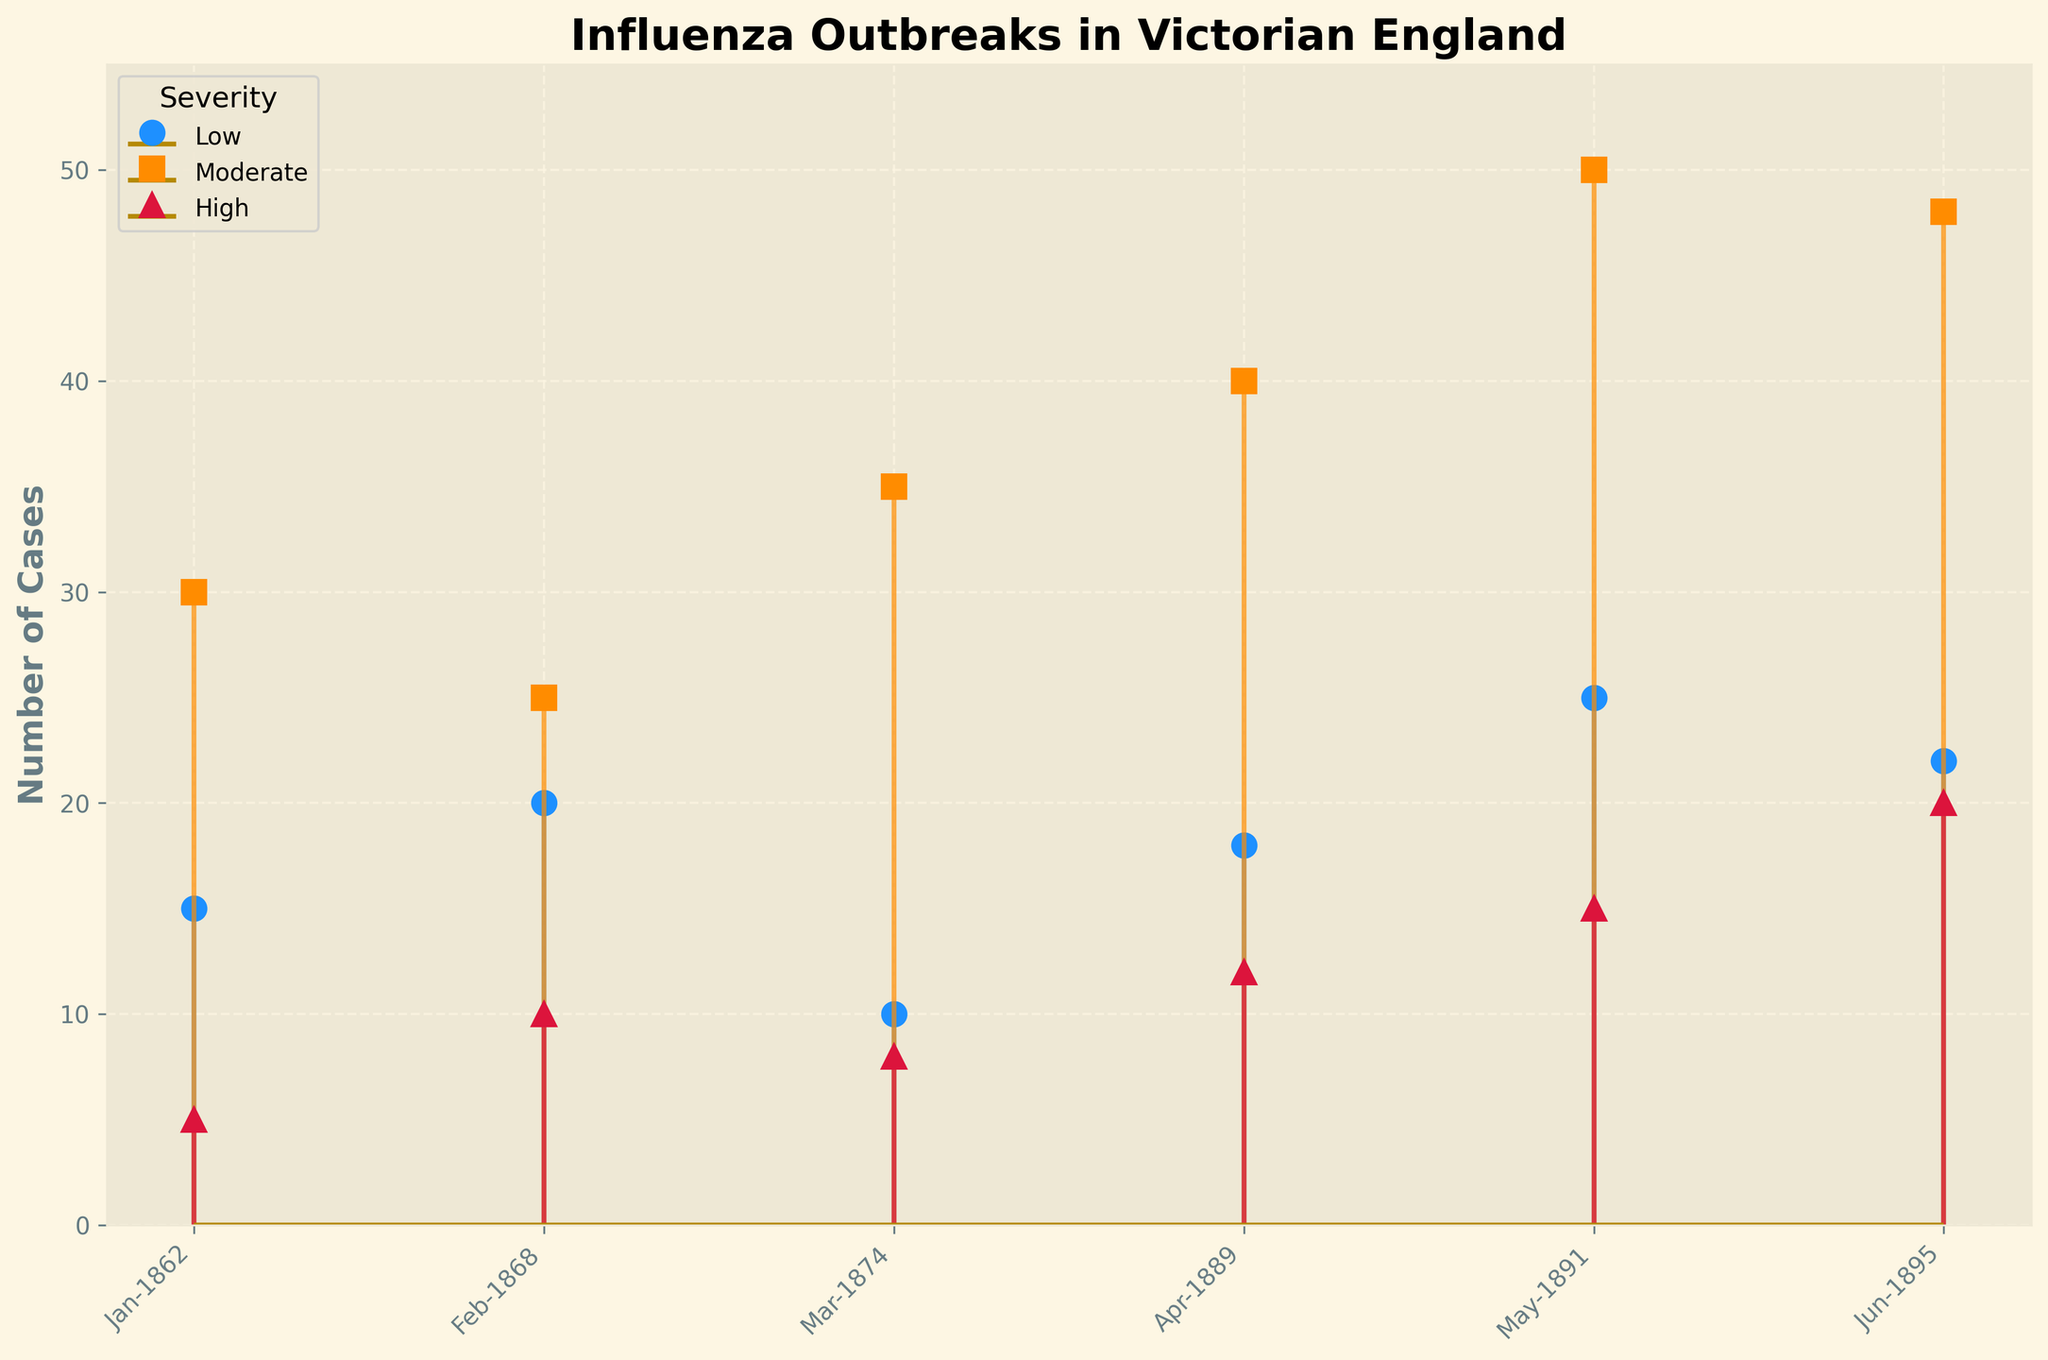What is the title of the figure? The title of the figure is prominently displayed at the top. It reads "Influenza Outbreaks in Victorian England."
Answer: Influenza Outbreaks in Victorian England How many cases of high severity occurred in May-1891? By identifying "May-1891" on the x-axis and looking at the corresponding value for high severity, we observe that it reaches up to the line marked with the highest number of cases, which is 15.
Answer: 15 Which month had the highest number of moderate severity cases? By examining the stem plot, we compare the lengths of the lines corresponding to moderate severity across all months. May-1891 has the longest line for moderate severity, so it had the highest number of cases.
Answer: May-1891 What is the range of cases reported for low severity across all months? To find the range, we determine the minimum and maximum values reported for low severity across the months. The minimum is 10 (Mar-1874) and the maximum is 25 (May-1891), leading to a range of 25 - 10 = 15.
Answer: 15 How do the high severity cases in Jun-1895 compare to those in Feb-1868? Looking at the lengths of the lines for high severity in these two months, Jun-1895 has 20 cases while Feb-1868 has 10 cases. Hence, Jun-1895 has more high severity cases than Feb-1868.
Answer: Jun-1895 has more cases What is the total number of cases reported in Apr-1889 across all severities? We sum up the cases for low, moderate, and high severity in Apr-1889: 18 (Low) + 40 (Moderate) + 12 (High) = 70.
Answer: 70 What is the average number of moderate severity cases per month? To calculate the average, sum all moderate severity values and divide by the number of months. Total cases: 30 + 25 + 35 + 40 + 50 + 48 = 228. Number of months: 6. Average = 228 / 6 = 38.
Answer: 38 In which month is the difference between low and high severity cases the greatest? By calculating the differences, we find: Jan-1862 (15-5=10), Feb-1868 (20-10=10), Mar-1874 (10-8=2), Apr-1889 (18-12=6), May-1891 (25-15=10), Jun-1895 (22-20=2). The months with the greatest difference are Jan-1862, Feb-1868, and May-1891, all with a difference of 10.
Answer: Jan-1862, Feb-1868, May-1891 How does the trend in moderate severity cases change over time from Jan-1862 to Jun-1895? Observing the pattern of the moderate severity cases over time, they generally increase with occasional drops: 30 (1862), 25 (1868), 35 (1874), 40 (1889), 50 (1891), 48 (1895). This shows a general rising trend over the years.
Answer: Increasing trend with occasional drops 